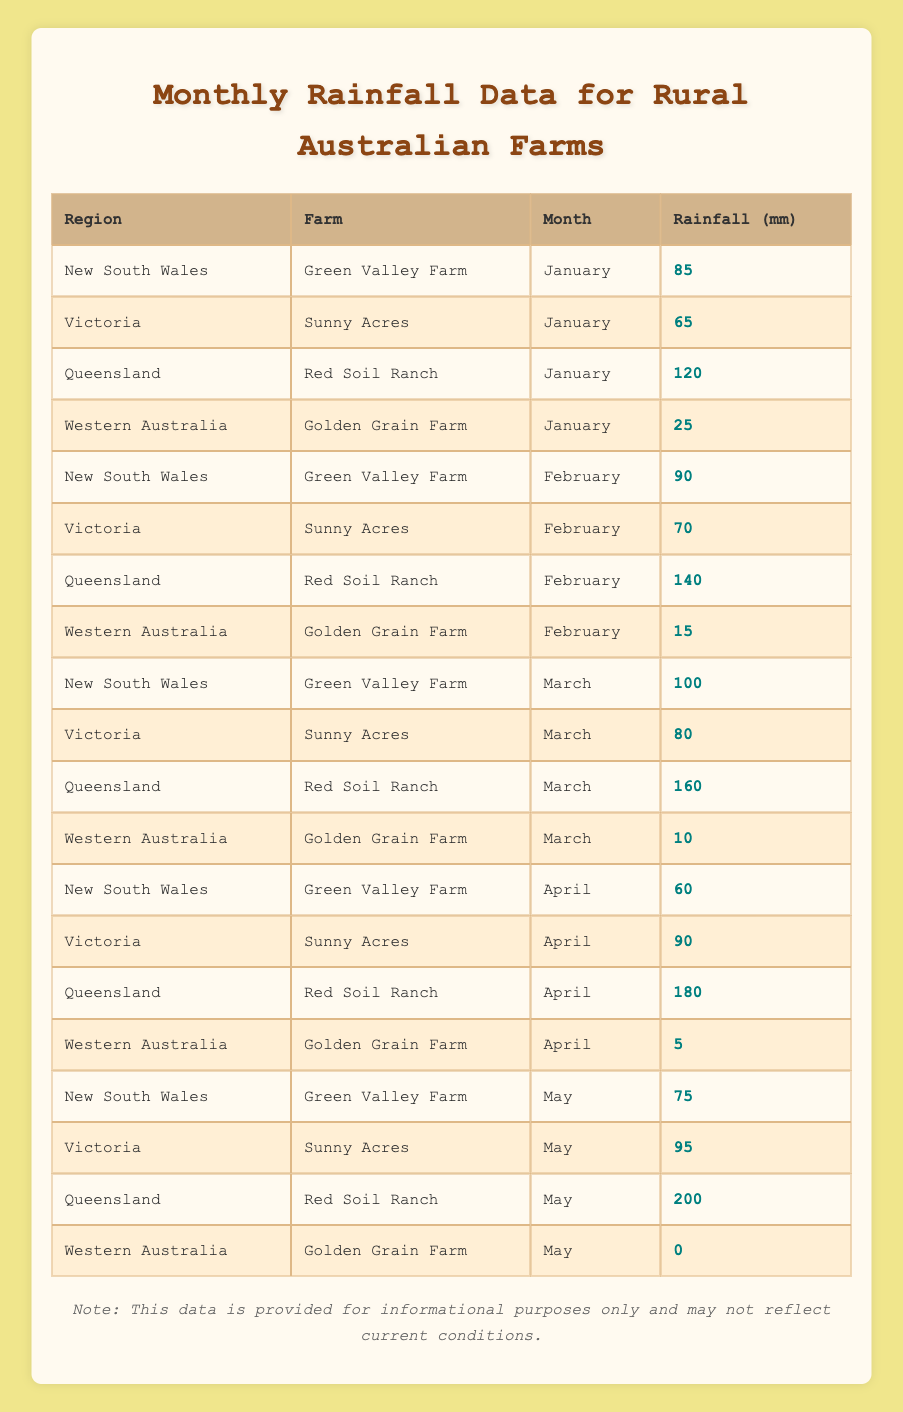What is the recorded rainfall for Green Valley Farm in March? The table shows that for Green Valley Farm located in New South Wales, the rainfall in March is 100 mm.
Answer: 100 mm Which farm received the least rainfall in May? Looking at the table for May, Golden Grain Farm in Western Australia received 0 mm of rainfall, which is the lowest compared to other farms listed.
Answer: Golden Grain Farm What is the total rainfall for Red Soil Ranch over the five months? For Red Soil Ranch in Queensland, the monthly rainfall data is: January (120), February (140), March (160), April (180), and May (200). Adding these up gives 120 + 140 + 160 + 180 + 200 = 800 mm total.
Answer: 800 mm Did Sunny Acres receive more rainfall in April than in January? Checking Sunny Acres in Victoria, the rainfall was 90 mm in April and 65 mm in January. Since 90 is greater than 65, it confirms that April had more rainfall.
Answer: Yes What is the average rainfall per month for Green Valley Farm? Green Valley Farm's monthly rainfall data is: January (85), February (90), March (100), April (60), and May (75). To find the average, the sum is 85 + 90 + 100 + 60 + 75 = 410 mm. The average is 410 divided by 5, which equals 82 mm.
Answer: 82 mm Which region had the maximum rainfall in February? Reviewing the rainfall data for February, Red Soil Ranch in Queensland received 140 mm, which is greater than any other farm's data for that month. Thus, the maximum rainfall was in Queensland.
Answer: Queensland What is the difference in rainfall between the highest and lowest recorded amounts for Golden Grain Farm? Golden Grain Farm's rainfall for the five months is: January (25), February (15), March (10), April (5), and May (0). The highest is 25 mm and the lowest is 0 mm, so the difference is 25 - 0 = 25 mm.
Answer: 25 mm In which month did Queensland experience its highest rainfall, and what was the amount? Looking through the data for Queensland (Red Soil Ranch), the monthly rainfall amounts are January (120), February (140), March (160), April (180), and May (200). The highest amount is in May at 200 mm.
Answer: May, 200 mm How much more rainfall did Sunny Acres receive in April compared to March? Sunny Acres had rainfall of 90 mm in April and 80 mm in March. The difference is 90 - 80 = 10 mm, indicating it received more rainfall in April.
Answer: 10 mm Is it true that Western Australia consistently received less rainfall than New South Wales in the first three months? For the first three months, the recorded rainfall for New South Wales is 85 mm (January), 90 mm (February), and 100 mm (March), while Western Australia received 25 mm, 15 mm, and 10 mm respectively. Since each month shows that NSW has more rainfall, the statement is true.
Answer: Yes 